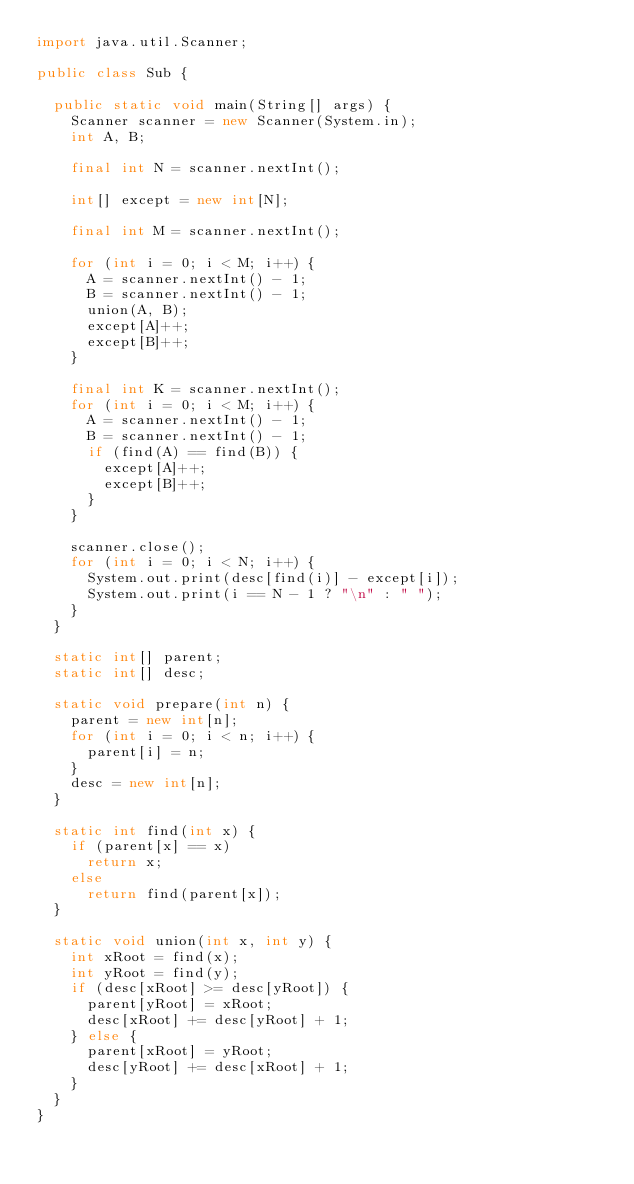Convert code to text. <code><loc_0><loc_0><loc_500><loc_500><_Java_>import java.util.Scanner;

public class Sub {

	public static void main(String[] args) {
		Scanner scanner = new Scanner(System.in);
		int A, B;

		final int N = scanner.nextInt();

		int[] except = new int[N];

		final int M = scanner.nextInt();

		for (int i = 0; i < M; i++) {
			A = scanner.nextInt() - 1;
			B = scanner.nextInt() - 1;
			union(A, B);
			except[A]++;
			except[B]++;
		}

		final int K = scanner.nextInt();
		for (int i = 0; i < M; i++) {
			A = scanner.nextInt() - 1;
			B = scanner.nextInt() - 1;
			if (find(A) == find(B)) {
				except[A]++;
				except[B]++;
			}
		}

		scanner.close();
		for (int i = 0; i < N; i++) {
			System.out.print(desc[find(i)] - except[i]);
			System.out.print(i == N - 1 ? "\n" : " ");
		}
	}

	static int[] parent;
	static int[] desc;

	static void prepare(int n) {
		parent = new int[n];
		for (int i = 0; i < n; i++) {
			parent[i] = n;
		}
		desc = new int[n];
	}

	static int find(int x) {
		if (parent[x] == x)
			return x;
		else
			return find(parent[x]);
	}

	static void union(int x, int y) {
		int xRoot = find(x);
		int yRoot = find(y);
		if (desc[xRoot] >= desc[yRoot]) {
			parent[yRoot] = xRoot;
			desc[xRoot] += desc[yRoot] + 1;
		} else {
			parent[xRoot] = yRoot;
			desc[yRoot] += desc[xRoot] + 1;
		}
	}
}
</code> 